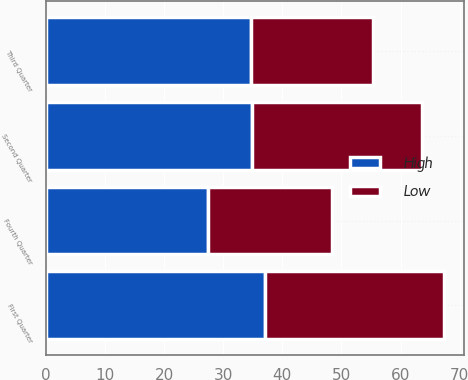Convert chart. <chart><loc_0><loc_0><loc_500><loc_500><stacked_bar_chart><ecel><fcel>First Quarter<fcel>Second Quarter<fcel>Third Quarter<fcel>Fourth Quarter<nl><fcel>High<fcel>37.07<fcel>34.81<fcel>34.73<fcel>27.51<nl><fcel>Low<fcel>30.25<fcel>28.75<fcel>20.66<fcel>20.89<nl></chart> 